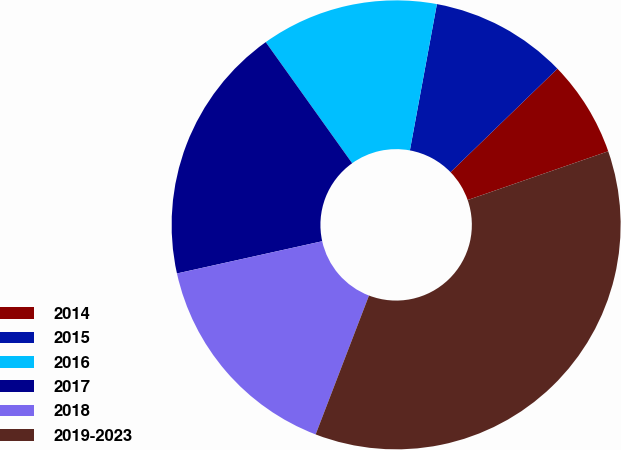Convert chart to OTSL. <chart><loc_0><loc_0><loc_500><loc_500><pie_chart><fcel>2014<fcel>2015<fcel>2016<fcel>2017<fcel>2018<fcel>2019-2023<nl><fcel>6.93%<fcel>9.85%<fcel>12.77%<fcel>18.61%<fcel>15.69%<fcel>36.15%<nl></chart> 